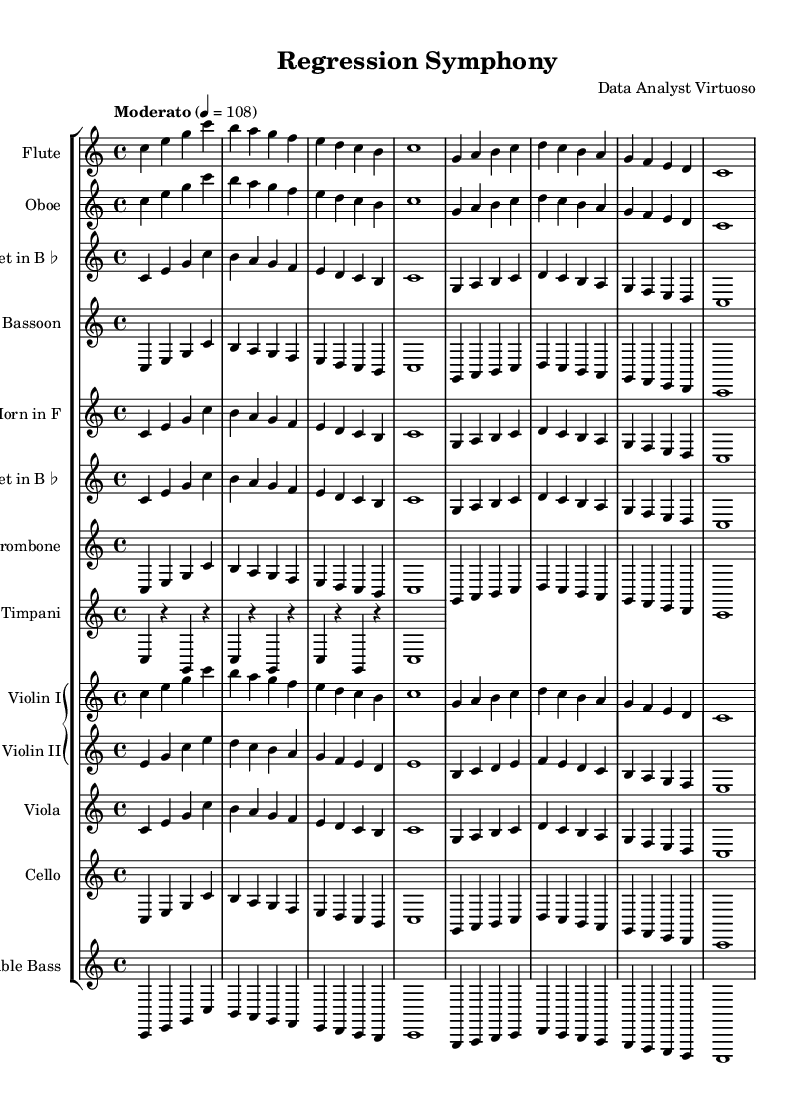What is the key signature of this music? The key signature indicated at the beginning of the score shows that it is C major, which has no sharps or flats. This is determined by the presence of no key signature symbols on the staff.
Answer: C major What is the time signature of this music? The time signature, displayed at the beginning of the score as 4/4, indicates that there are four beats in each measure and a quarter note receives one beat. This is found near the clef at the start of the score.
Answer: 4/4 What is the tempo of this piece? The tempo marking says "Moderato" with a metronome marking of 4 = 108, meaning the piece is to be played moderately fast at a rate of 108 beats per minute. This is located at the beginning section of the score.
Answer: Moderato 4 = 108 How many distinct instruments are present in this symphony? By counting the unique staff lines in the score, we establish the presence of thirteen distinct instruments, including strings and woodwinds. Each instrument type is represented by its own staff.
Answer: Thirteen In which section does the flute play in the symphony? The flute plays in the woodwind section, as indicated by its placement among the other woodwinds in the score layout, including the oboe, clarinet, and bassoon.
Answer: Woodwind What type of musical form is predominantly used in this symphony? The repeating melodic phrases in sequence indicate that this work uses a thematic structure often associated with classical forms like sonata or rondo, as can be inferred from the structure of the score.
Answer: Thematic structure How is the role of the timpani characterized in this piece? The timpani, notated with rests between notes, provides rhythmic emphasis in this symphony, serving to mark important beats and changes in musical sections, evident in its unique notation.
Answer: Rhythmic emphasis 